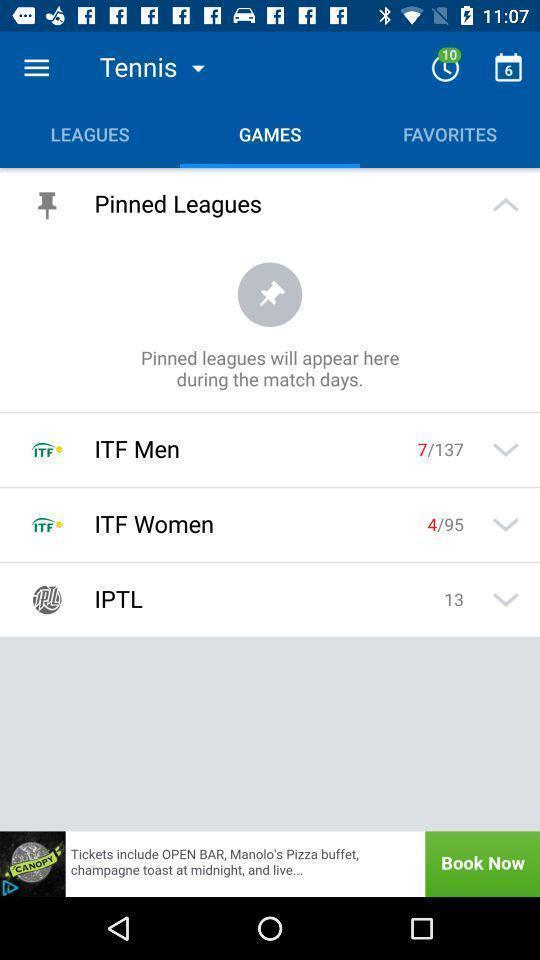Describe the content in this image. Tennis match informations are displaying. 